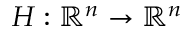Convert formula to latex. <formula><loc_0><loc_0><loc_500><loc_500>H \colon \mathbb { R } ^ { n } \rightarrow \mathbb { R } ^ { n }</formula> 